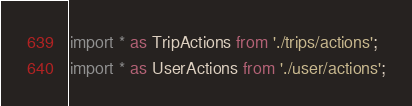Convert code to text. <code><loc_0><loc_0><loc_500><loc_500><_JavaScript_>import * as TripActions from './trips/actions';
import * as UserActions from './user/actions';</code> 